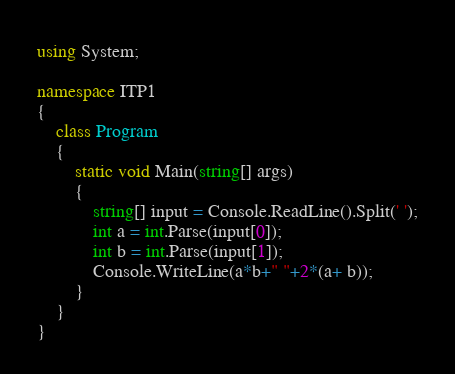<code> <loc_0><loc_0><loc_500><loc_500><_C#_>using System;

namespace ITP1
{
    class Program
    {
        static void Main(string[] args)
        {
            string[] input = Console.ReadLine().Split(' ');
            int a = int.Parse(input[0]);
            int b = int.Parse(input[1]);
            Console.WriteLine(a*b+" "+2*(a+ b));
        }
    }
}</code> 